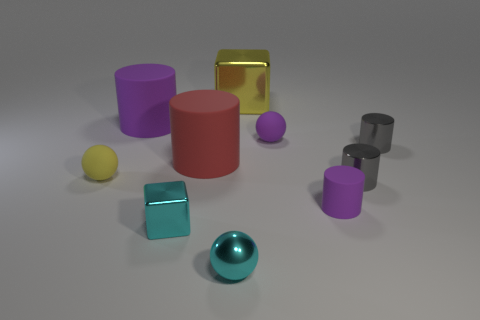Subtract all tiny cyan balls. How many balls are left? 2 Subtract all red balls. How many gray cylinders are left? 2 Subtract all spheres. How many objects are left? 7 Subtract all cyan balls. How many balls are left? 2 Subtract 1 yellow spheres. How many objects are left? 9 Subtract 4 cylinders. How many cylinders are left? 1 Subtract all green blocks. Subtract all red cylinders. How many blocks are left? 2 Subtract all red matte cylinders. Subtract all yellow spheres. How many objects are left? 8 Add 5 small purple rubber things. How many small purple rubber things are left? 7 Add 9 tiny blue cubes. How many tiny blue cubes exist? 9 